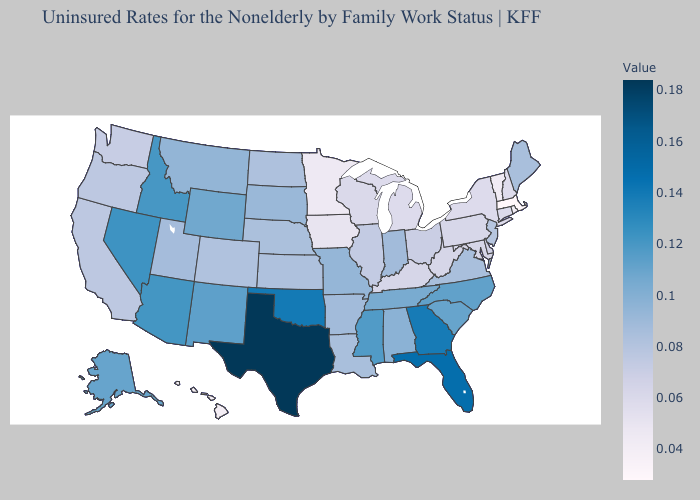Does Indiana have the lowest value in the USA?
Quick response, please. No. Does Hawaii have the lowest value in the West?
Give a very brief answer. Yes. Which states hav the highest value in the South?
Short answer required. Texas. Is the legend a continuous bar?
Give a very brief answer. Yes. Does Mississippi have a higher value than Florida?
Write a very short answer. No. Among the states that border Idaho , which have the lowest value?
Write a very short answer. Washington. 